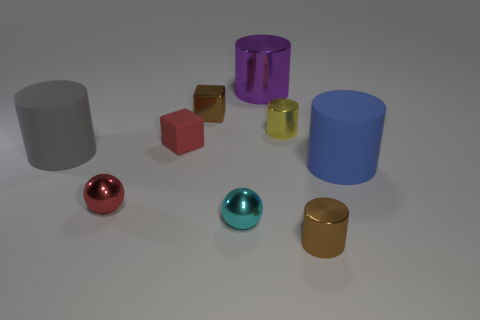Subtract 1 cylinders. How many cylinders are left? 4 Subtract all green cylinders. Subtract all purple blocks. How many cylinders are left? 5 Add 1 small yellow cylinders. How many objects exist? 10 Subtract all blocks. How many objects are left? 7 Subtract all cyan metallic balls. Subtract all large gray matte objects. How many objects are left? 7 Add 6 large blue matte objects. How many large blue matte objects are left? 7 Add 4 big brown cylinders. How many big brown cylinders exist? 4 Subtract 1 brown blocks. How many objects are left? 8 